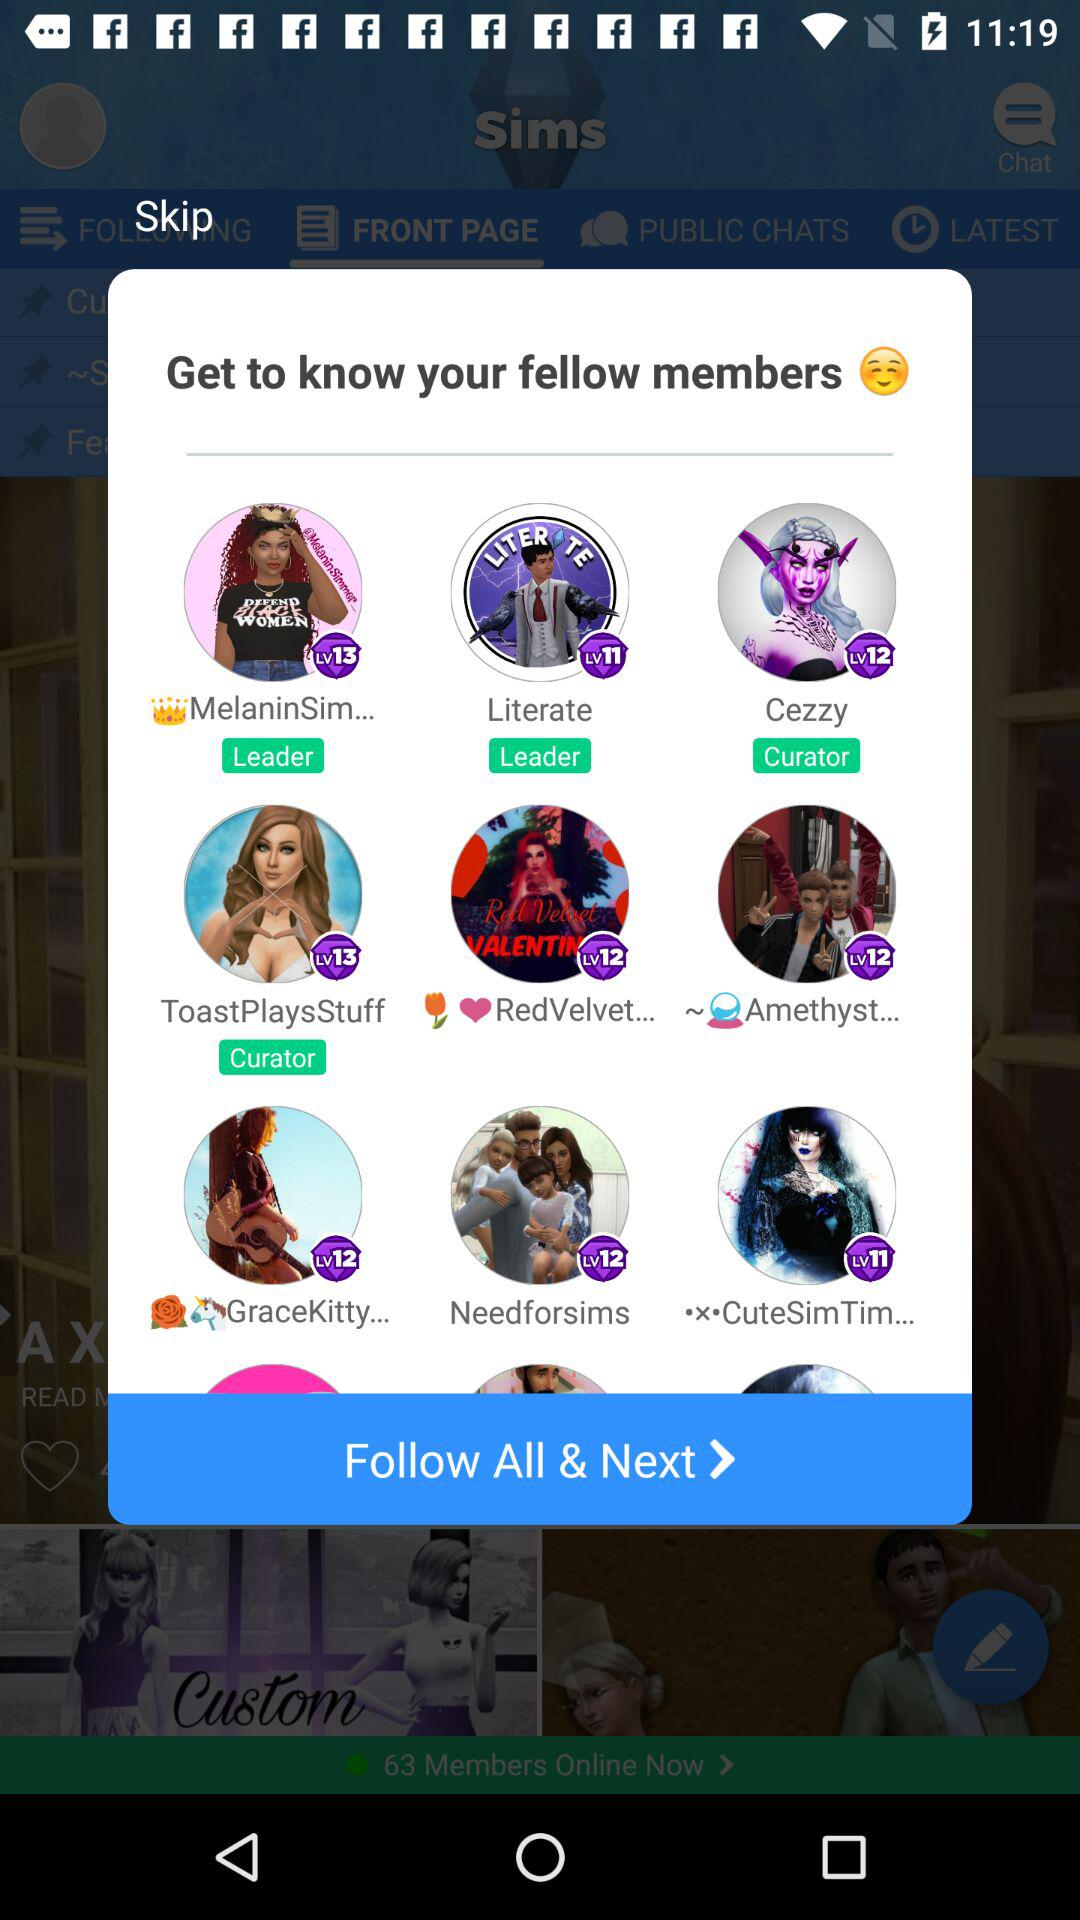Which member has the highest level?
Answer the question using a single word or phrase. MelaninSim 